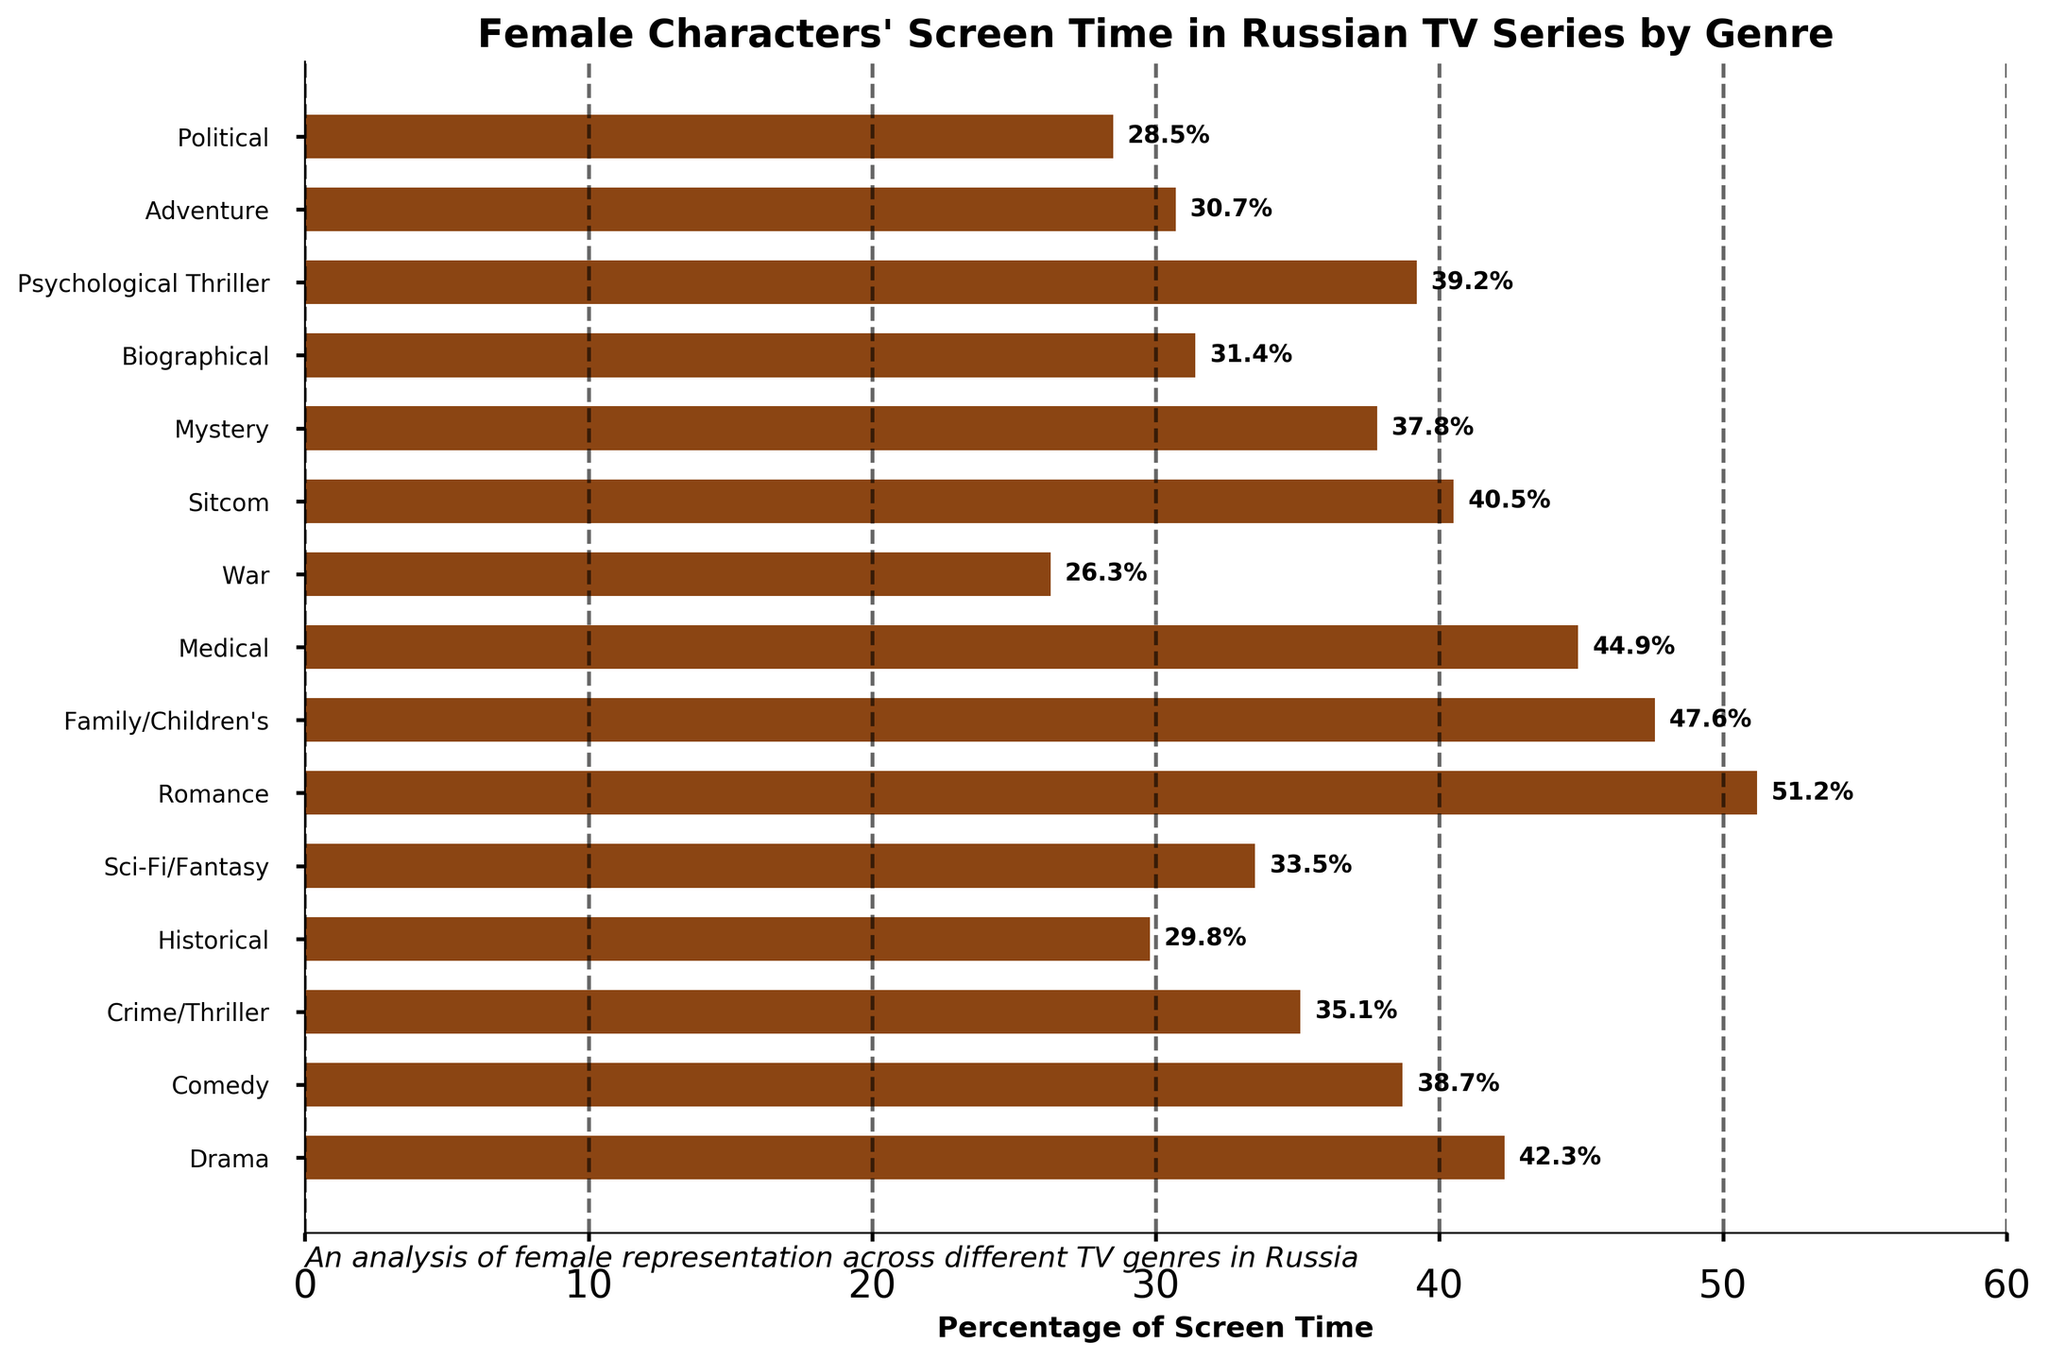What genre has the highest percentage of screen time given to female characters? The highest bar represents the genre with the highest percentage. By looking at the heights of the bars, Romance has the highest percentage of 51.2%.
Answer: Romance Which genre has the lowest percentage of screen time given to female characters? The lowest bar indicates the genre with the lowest percentage. By visually identifying the shortest bar, War has the lowest percentage of 26.3%.
Answer: War How much more percentage of screen time is given to female characters in Romance compared to Crime/Thriller? Subtract the percentage of Crime/Thriller from the percentage of Romance: 51.2% - 35.1% = 16.1%.
Answer: 16.1% What is the median percentage of screen time among all genres? To find the median, list all percentages in ascending order and identify the middle value: 26.3, 28.5, 29.8, 30.7, 31.4, 33.5, 35.1, 37.8, 38.7, 39.2, 40.5, 42.3, 44.9, 47.6, 51.2. The middle value is 37.8%.
Answer: 37.8% Which genre shows a percentage of screen time closest to the average percentage across all genres? First, calculate the average: sum all percentages and divide by the number of genres: (42.3 + 38.7 + 35.1 + 29.8 + 33.5 + 51.2 + 47.6 + 44.9 + 26.3 + 40.5 + 37.8 + 31.4 + 39.2 + 30.7 + 28.5)/15 = 37.8%. Then, compare each genre's percentage to find the closest value, which is also 37.8% (Mystery).
Answer: Mystery By what percentage does Family/Children's screen time exceed Comedy's? Subtract the percentage of Comedy from Family/Children's: 47.6% - 38.7% = 8.9%.
Answer: 8.9% Which genre has a higher percentage of female screen time: Biographical or Political? Compare the two percentages directly: Biographical (31.4%) is higher than Political (28.5%).
Answer: Biographical What is the difference in percentage points between Sci-Fi/Fantasy and Drama? Subtract the percentage of Sci-Fi/Fantasy from Drama: 42.3% - 33.5% = 8.8%.
Answer: 8.8% Identify two genres where the percentage of female screen time is greater than 40% but less than 45%. By examining the height of the bars, Drama (42.3%) and Sitcom (40.5%) both fall within this range.
Answer: Drama and Sitcom Estimate the range of percentages of screen time given to female characters across all genres. The range is calculated by subtracting the smallest percentage from the largest percentage: 51.2% (Romance) - 26.3% (War) = 24.9%.
Answer: 24.9% 